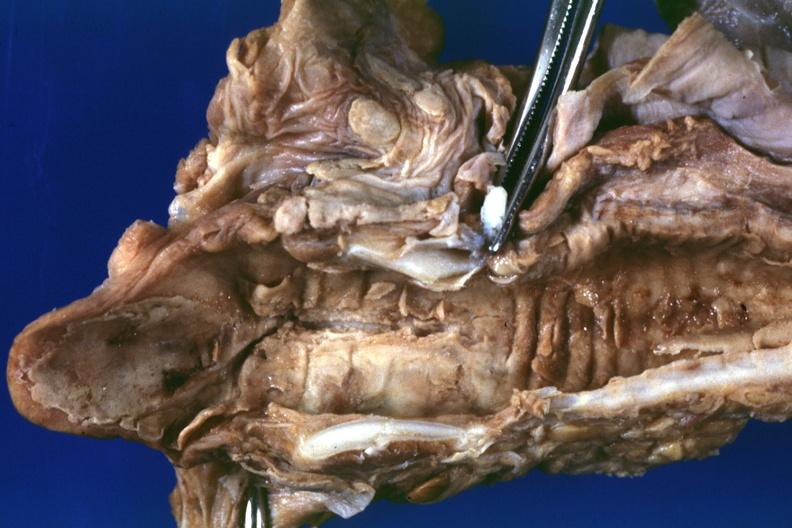how does this image show severe necrotizing lesion in mucosa good example also a in file 33 year old female?
Answer the question using a single word or phrase. With adenoid cystic carcinoma of trachea a19-88 